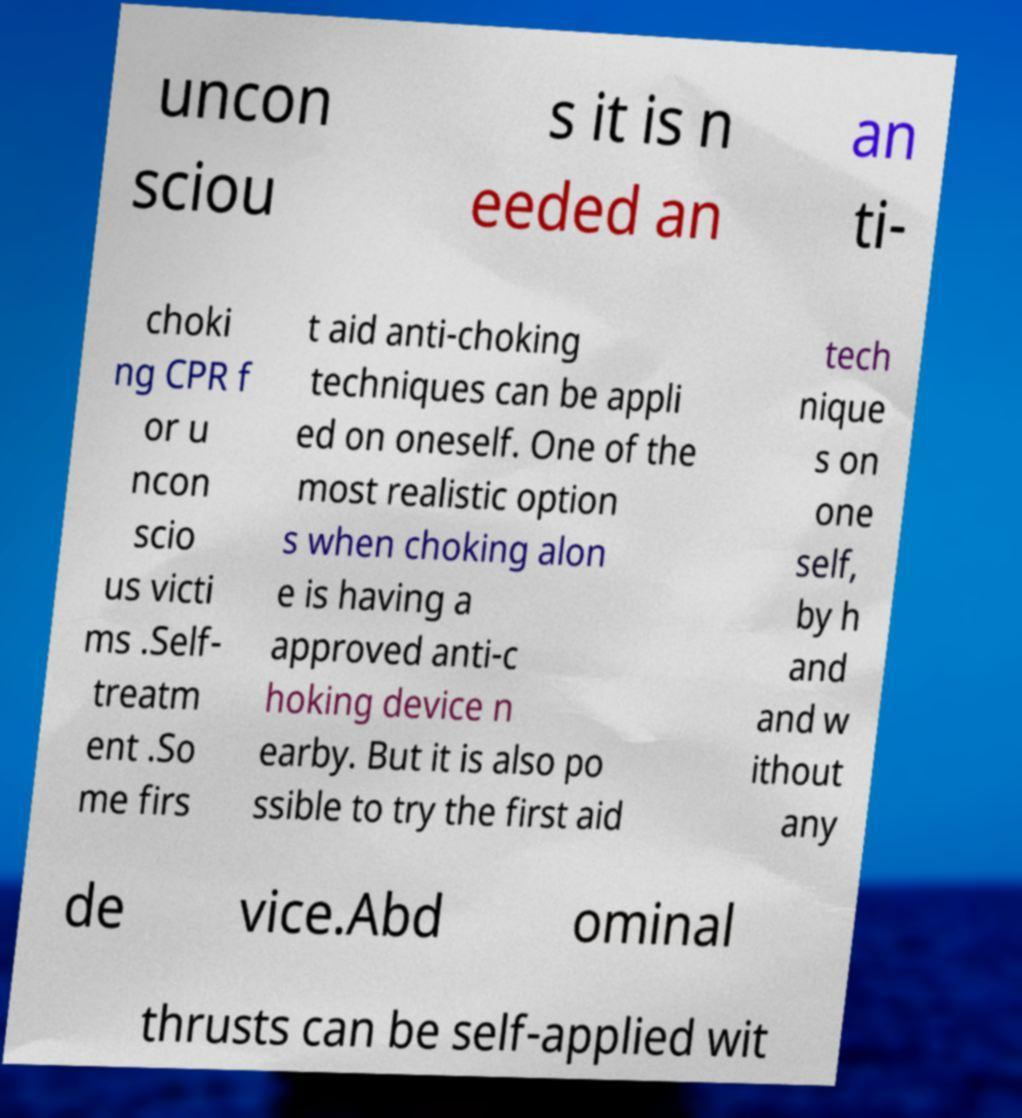I need the written content from this picture converted into text. Can you do that? uncon sciou s it is n eeded an an ti- choki ng CPR f or u ncon scio us victi ms .Self- treatm ent .So me firs t aid anti-choking techniques can be appli ed on oneself. One of the most realistic option s when choking alon e is having a approved anti-c hoking device n earby. But it is also po ssible to try the first aid tech nique s on one self, by h and and w ithout any de vice.Abd ominal thrusts can be self-applied wit 